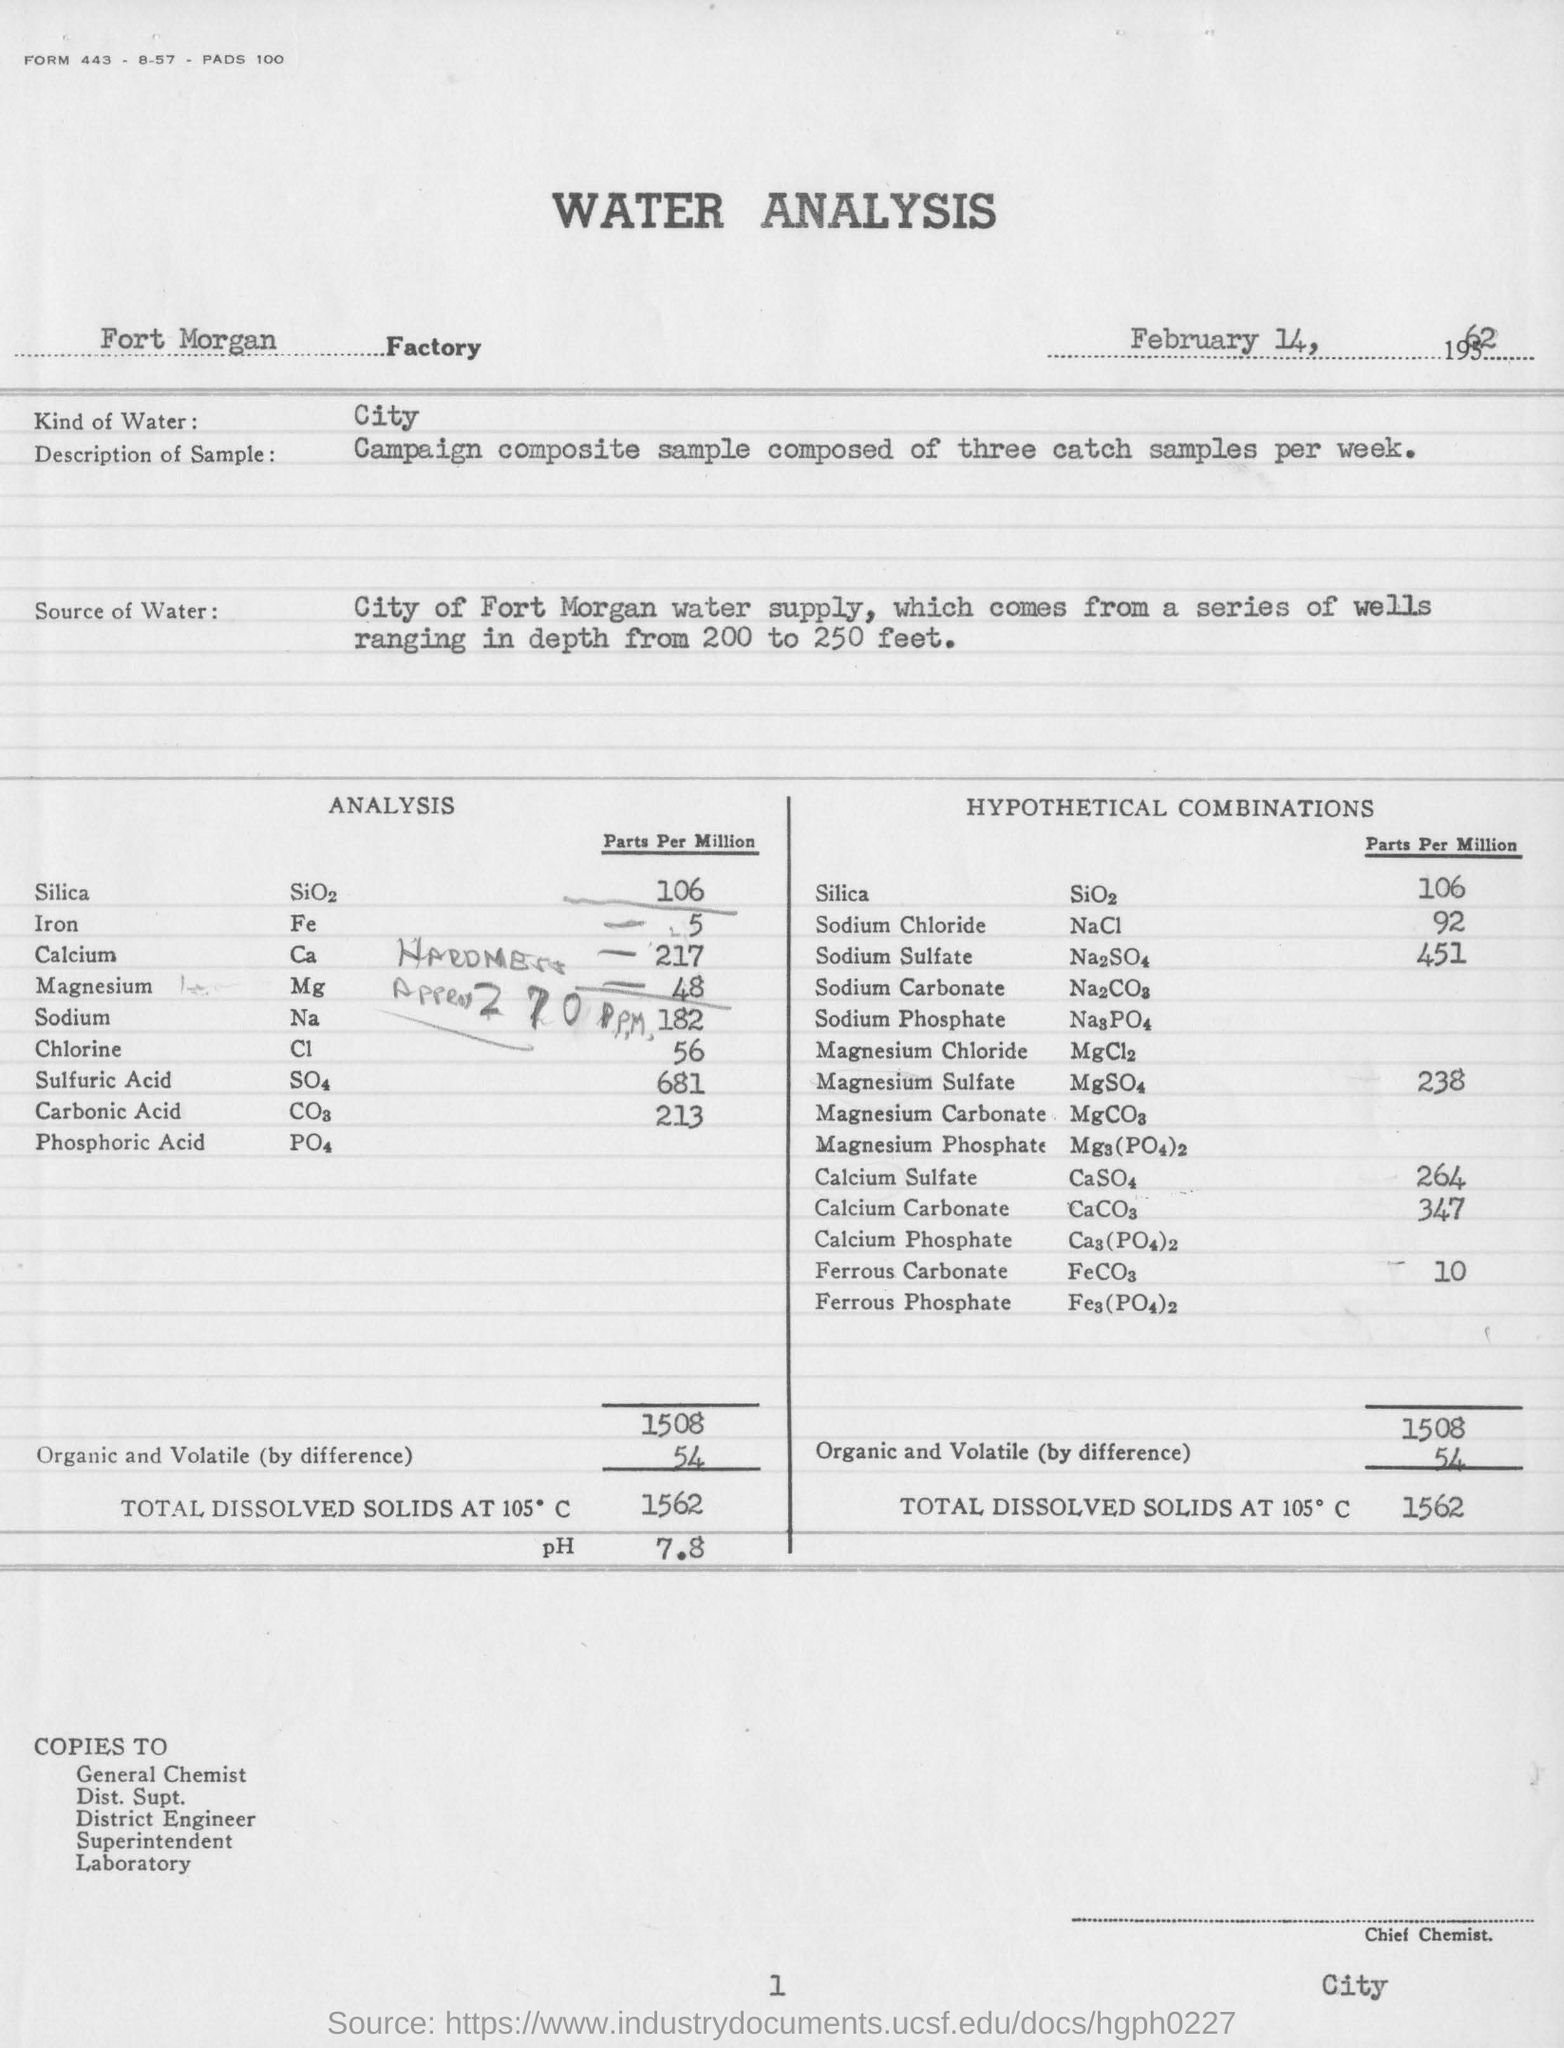What is the name of the factory ?
Your answer should be very brief. Fort morgan factory. What kind of water is used in water analysis ?
Your answer should be very brief. City. In analysis,what is the parts per million value of silica ?
Provide a short and direct response. 106. What is the amount of total dissolved solids at 105 degrees c ?
Your response must be concise. 1562. What is the ph value obtained in the water analysis ?
Make the answer very short. 7.8. In hypothetical combinations,what is the parts per million value of sodium chloride ?
Offer a terse response. 92. 